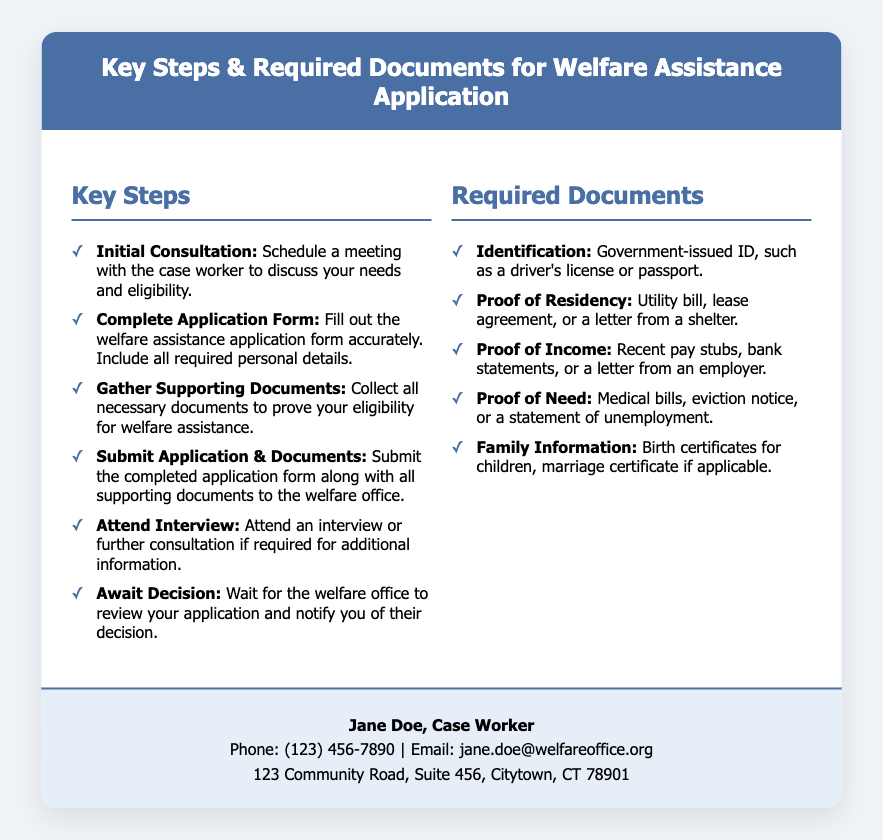what is the title of the document? The title is presented at the top of the document and identifies its purpose clearly.
Answer: Key Steps & Required Documents for Welfare Assistance Application who should you contact for assistance? The contact information is provided in the document for the case worker.
Answer: Jane Doe what phone number can be used to reach the case worker? The document lists a specific phone number for contact with the case worker.
Answer: (123) 456-7890 how many key steps are listed in the document? The document includes a section delineating the steps involved in the application process.
Answer: Six what type of identification is needed for the application? The required documents specify the type of identification to submit with the application.
Answer: Government-issued ID which document serves as proof of residency? The list includes various documents to establish residency requirements for welfare assistance.
Answer: Utility bill what must you do after submitting your application? The process outlines next steps following the submission of the application form.
Answer: Await Decision what is required to prove your need for assistance? The document provides examples of documentation that can demonstrate the need for welfare assistance.
Answer: Medical bills which section contains specific examples of required documents? The structure of the document separates information into distinct sections for clarity.
Answer: Required Documents 